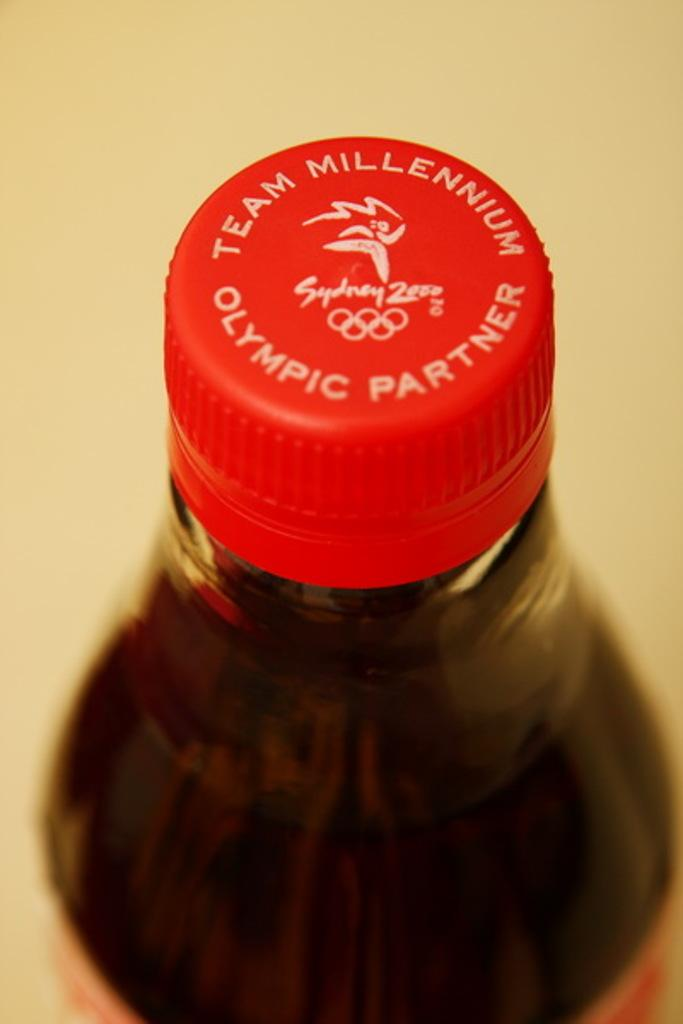<image>
Describe the image concisely. An up close image of a red bottle cap with the words Olympic Partner written on the top of it. 